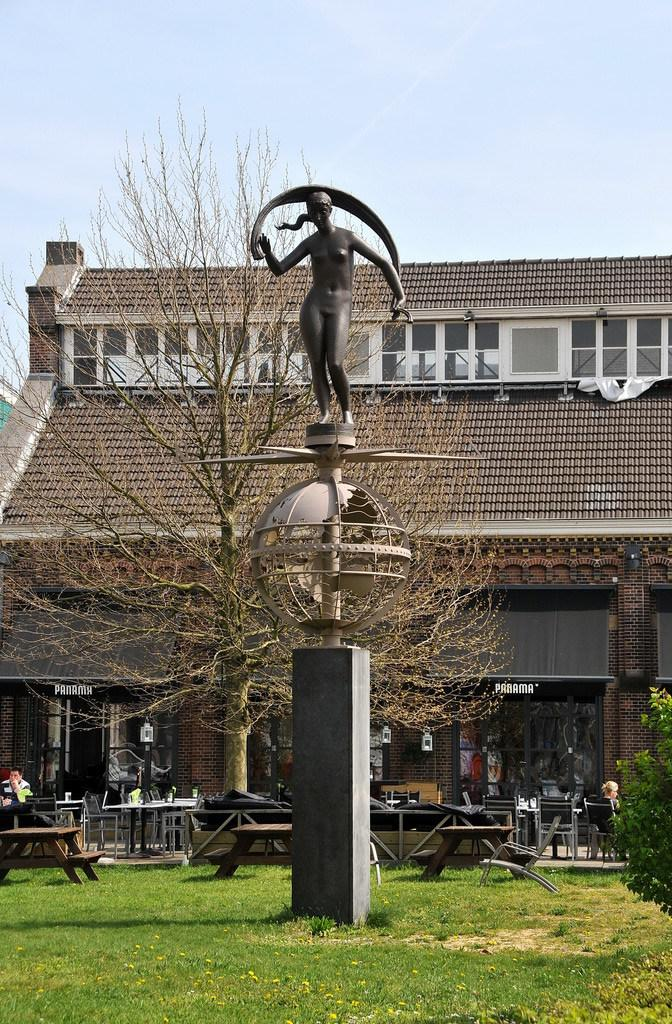What is the main structure in the image? There is a pillar in the image. What is on top of the pillar? There is a sculpture on top of the pillar. What can be seen in the background of the image? There is a tree, tables, a building, and the sky visible in the background of the image. What type of fruit is hanging from the pillar in the image? There is no fruit hanging from the pillar in the image. Is there a dock visible in the image? There is no dock present in the image. 